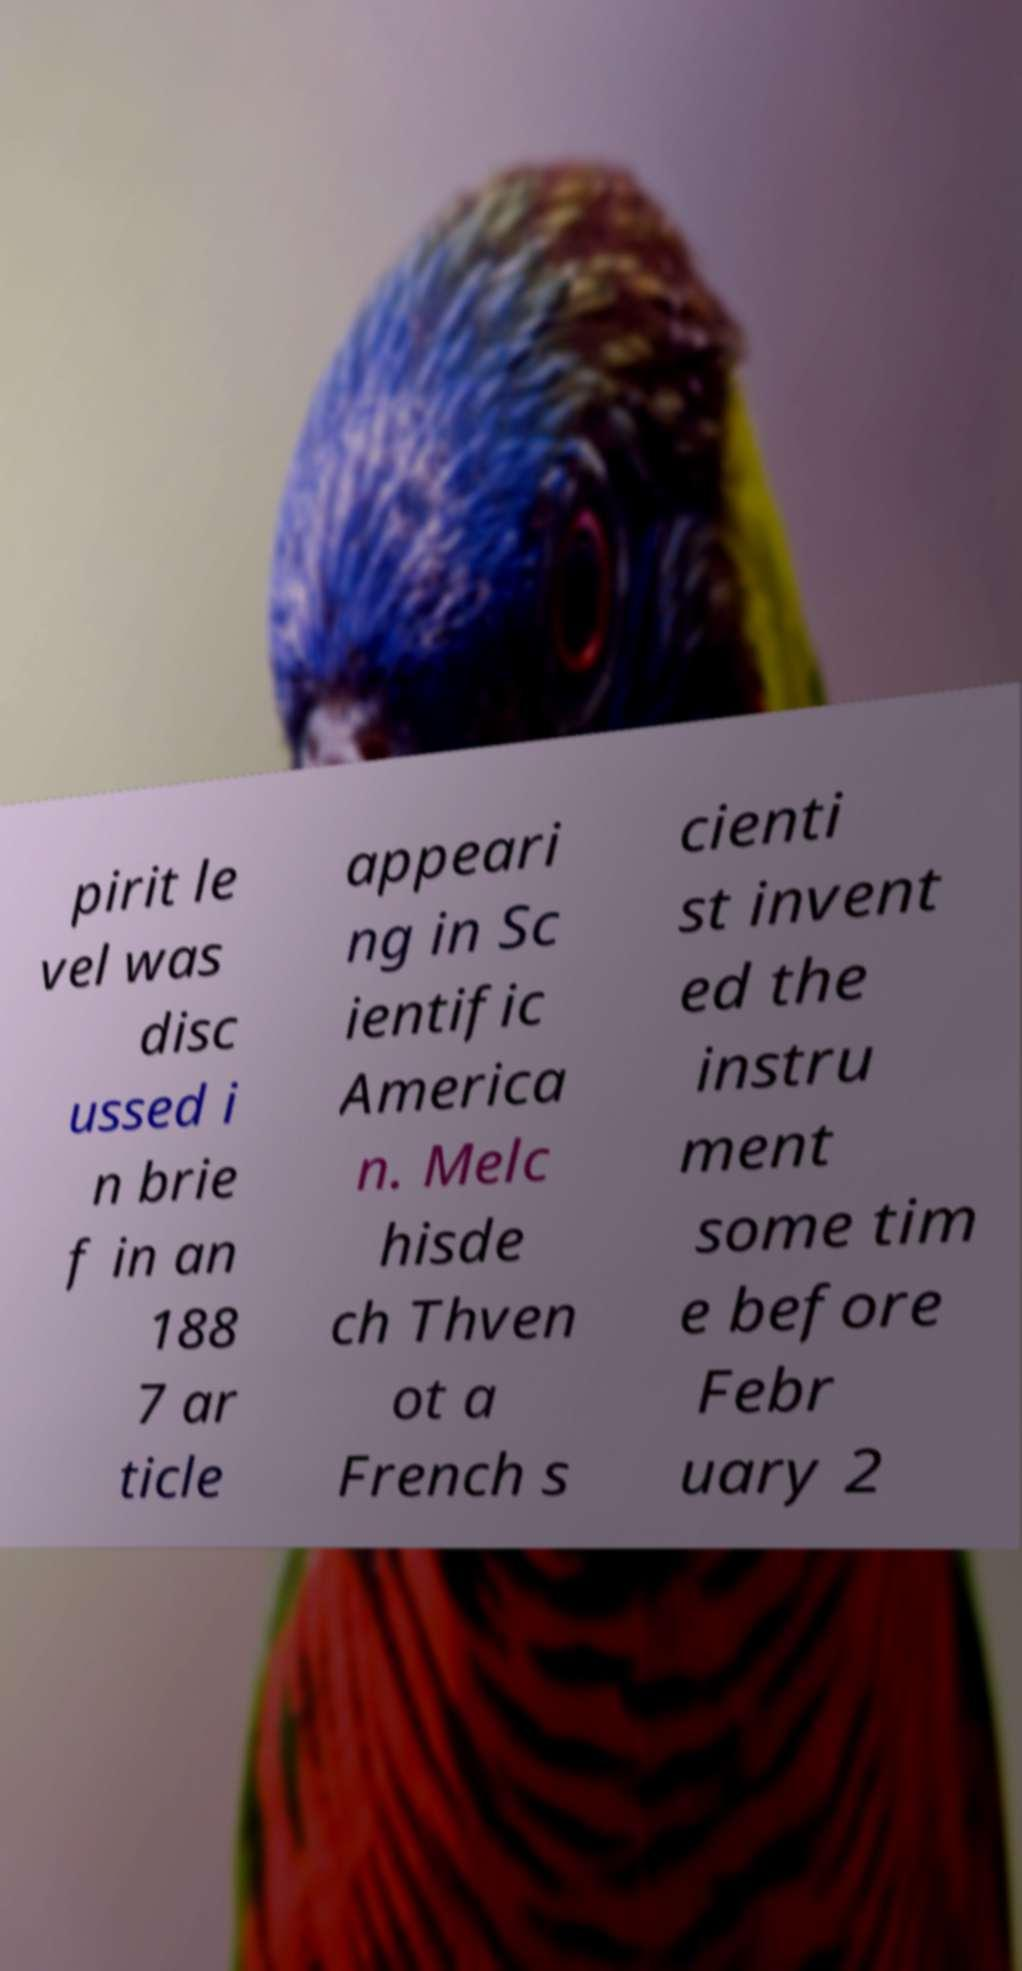Can you accurately transcribe the text from the provided image for me? pirit le vel was disc ussed i n brie f in an 188 7 ar ticle appeari ng in Sc ientific America n. Melc hisde ch Thven ot a French s cienti st invent ed the instru ment some tim e before Febr uary 2 